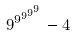Convert formula to latex. <formula><loc_0><loc_0><loc_500><loc_500>9 ^ { 9 ^ { 9 ^ { 9 ^ { 9 } } } } - 4</formula> 